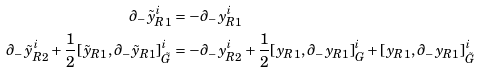<formula> <loc_0><loc_0><loc_500><loc_500>\partial _ { - } \tilde { y } _ { R 1 } ^ { i } & = - \partial _ { - } y _ { R 1 } ^ { i } \\ \partial _ { - } \tilde { y } _ { R 2 } ^ { i } + \frac { 1 } { 2 } [ \tilde { y } _ { R 1 } , \partial _ { - } \tilde { y } _ { R 1 } ] _ { \tilde { G } } ^ { i } & = - \partial _ { - } y _ { R 2 } ^ { i } + \frac { 1 } { 2 } [ y _ { R 1 } , \partial _ { - } y _ { R 1 } ] _ { G } ^ { i } + [ y _ { R 1 } , \partial _ { - } y _ { R 1 } ] _ { \tilde { G } } ^ { i }</formula> 